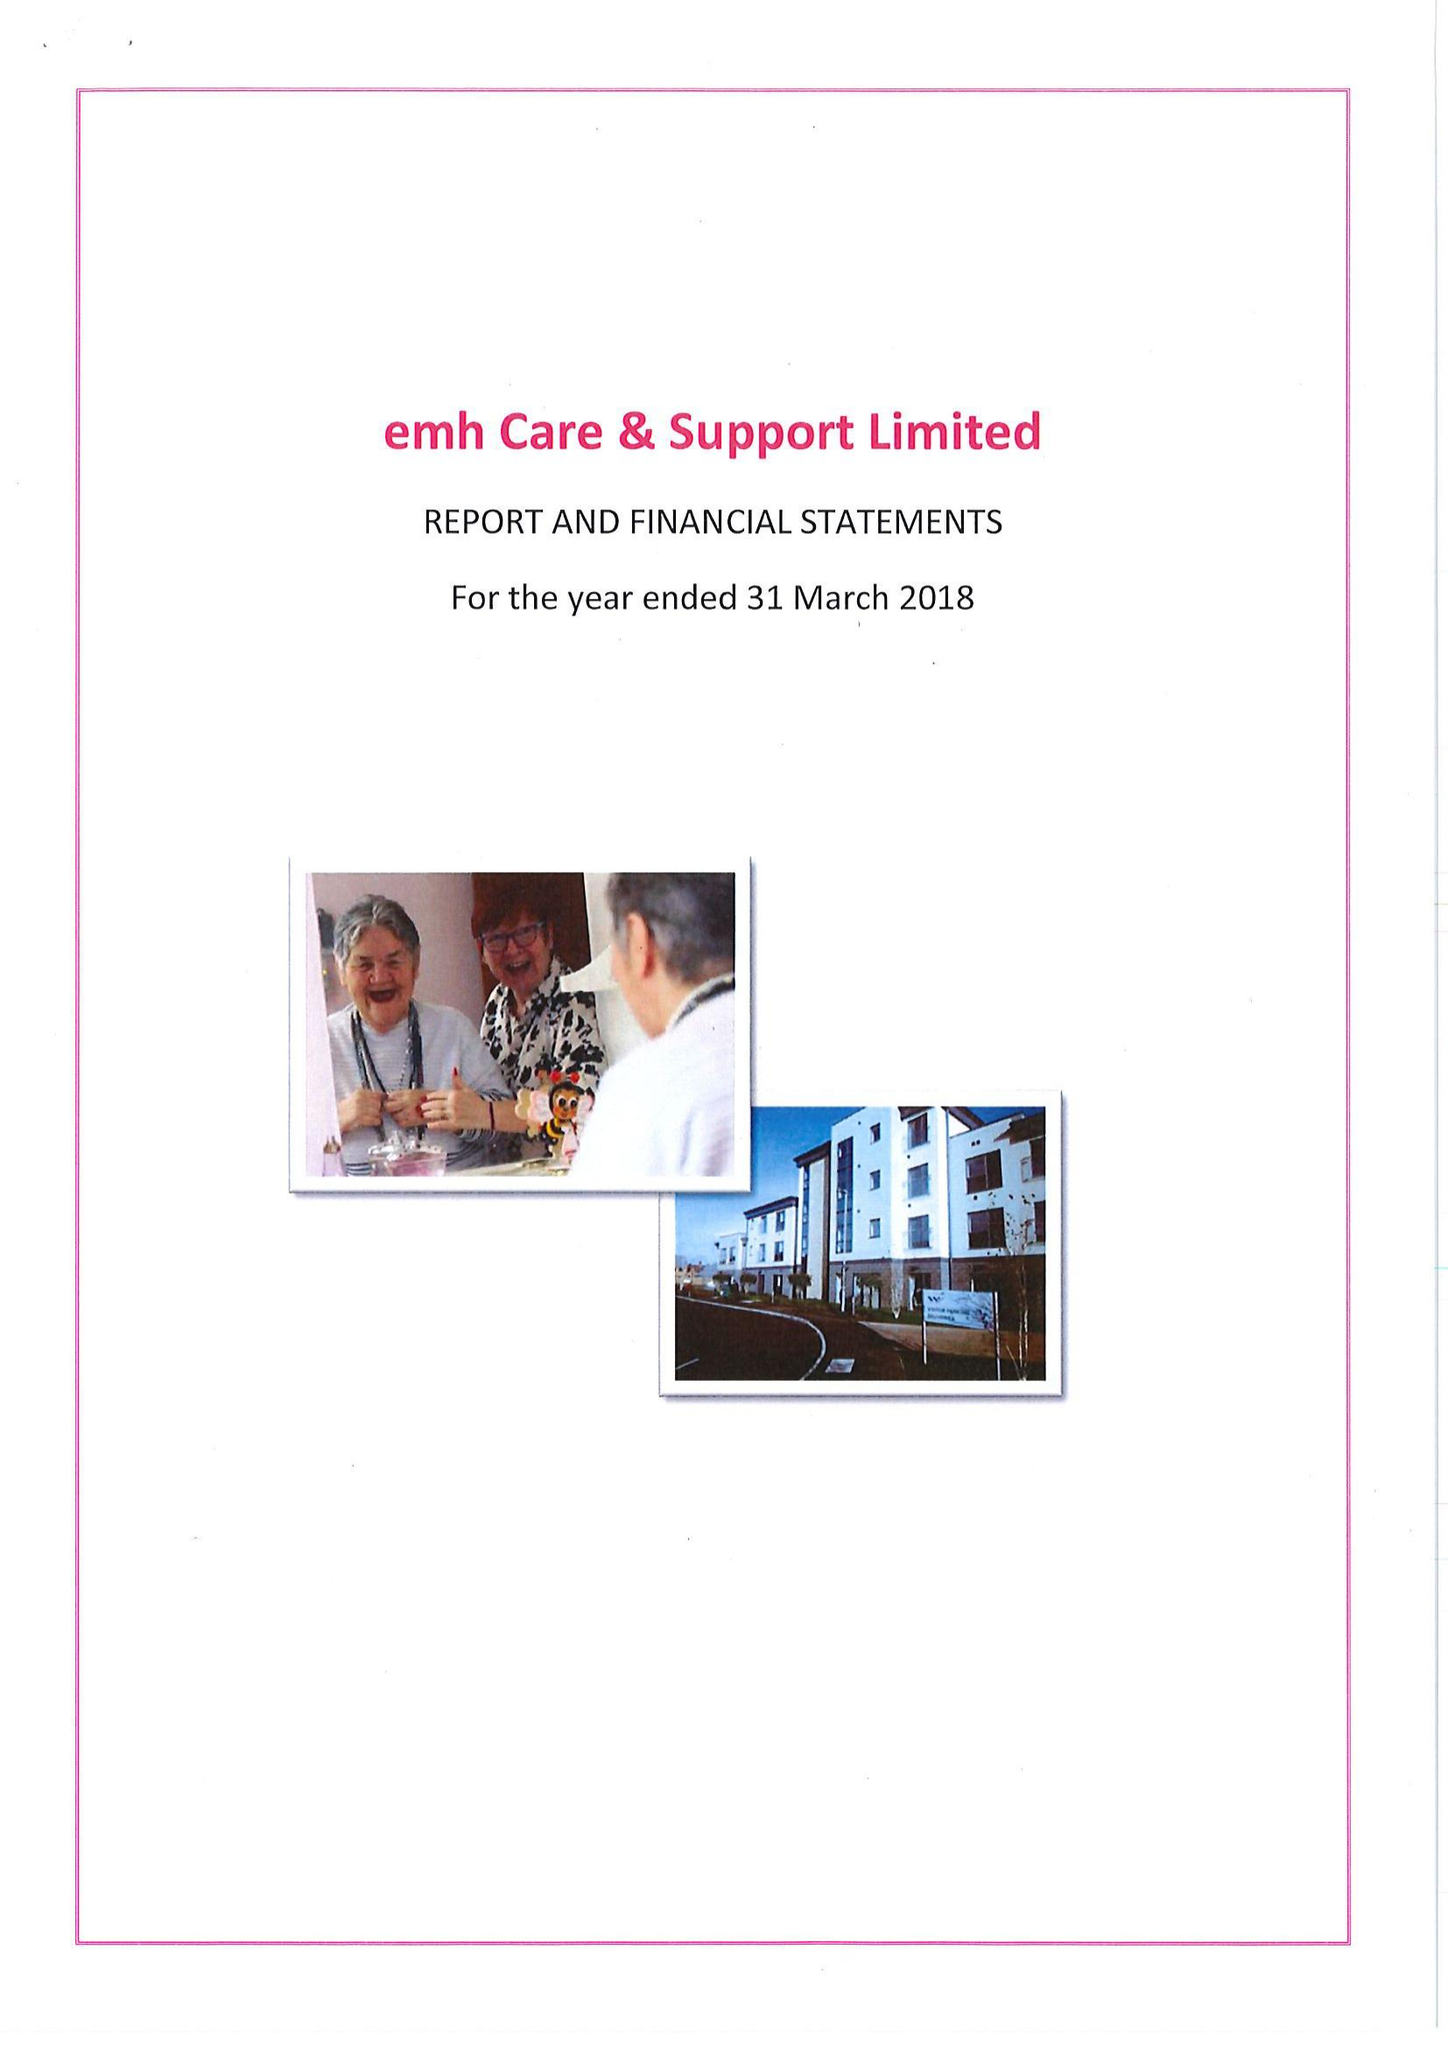What is the value for the spending_annually_in_british_pounds?
Answer the question using a single word or phrase. 15566000.00 